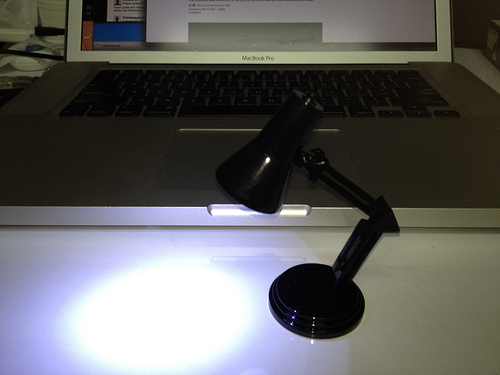<image>
Is there a lamp on the table? Yes. Looking at the image, I can see the lamp is positioned on top of the table, with the table providing support. 